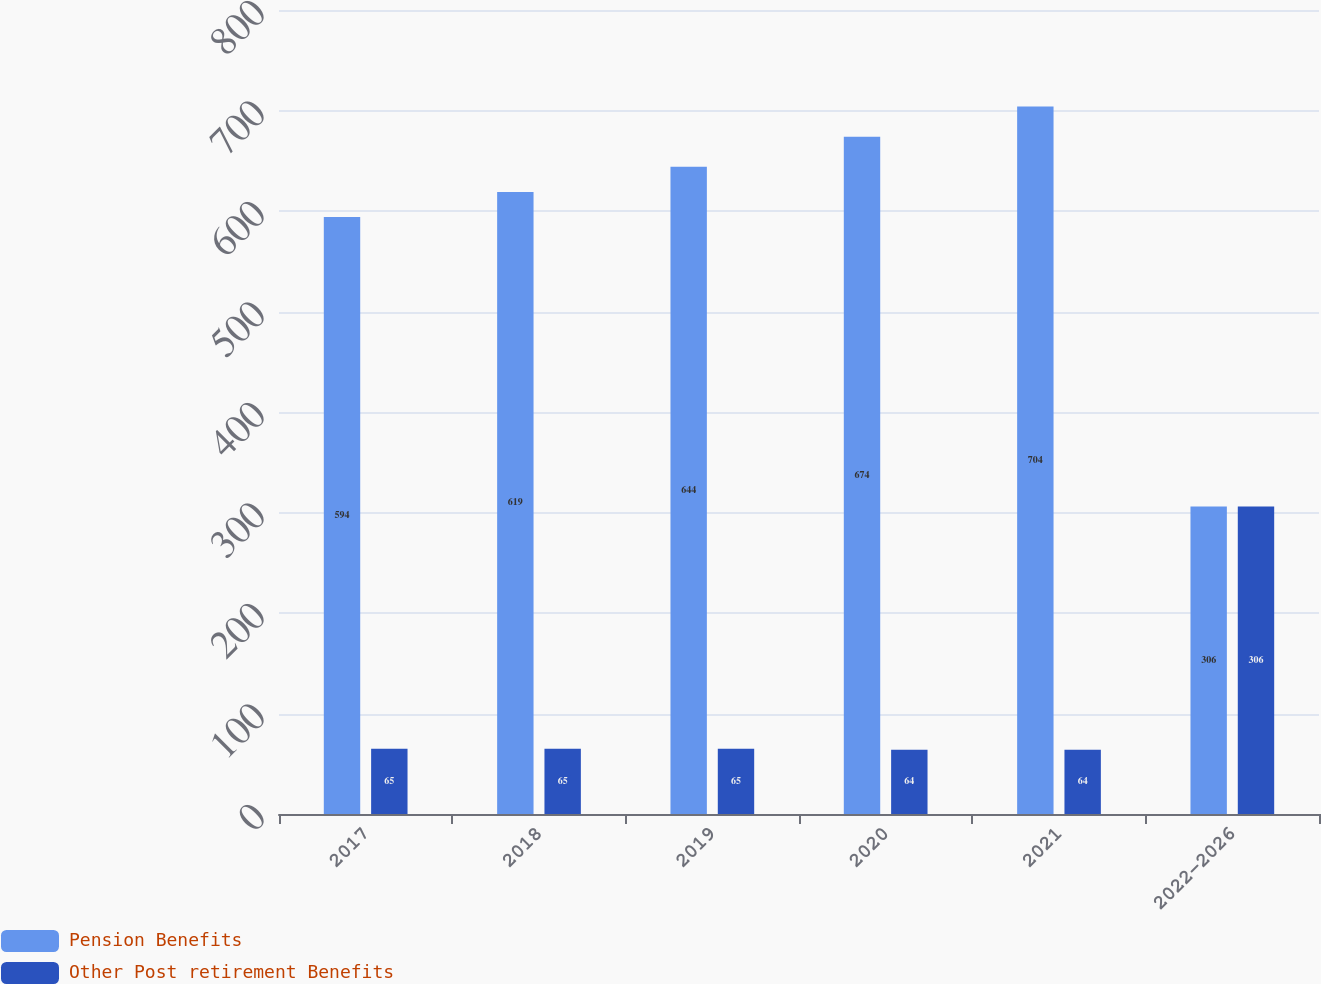<chart> <loc_0><loc_0><loc_500><loc_500><stacked_bar_chart><ecel><fcel>2017<fcel>2018<fcel>2019<fcel>2020<fcel>2021<fcel>2022-2026<nl><fcel>Pension Benefits<fcel>594<fcel>619<fcel>644<fcel>674<fcel>704<fcel>306<nl><fcel>Other Post retirement Benefits<fcel>65<fcel>65<fcel>65<fcel>64<fcel>64<fcel>306<nl></chart> 